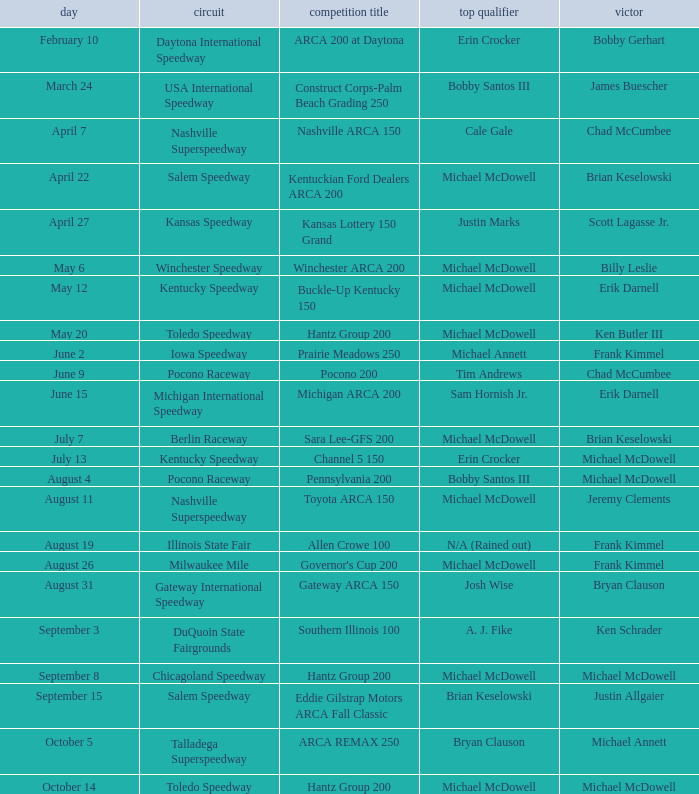Tell me the pole winner of may 12 Michael McDowell. 